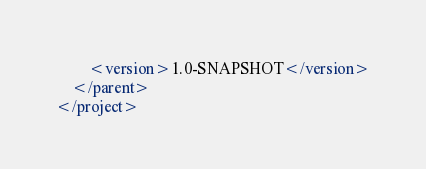Convert code to text. <code><loc_0><loc_0><loc_500><loc_500><_XML_>        <version>1.0-SNAPSHOT</version>
    </parent>
</project>
</code> 